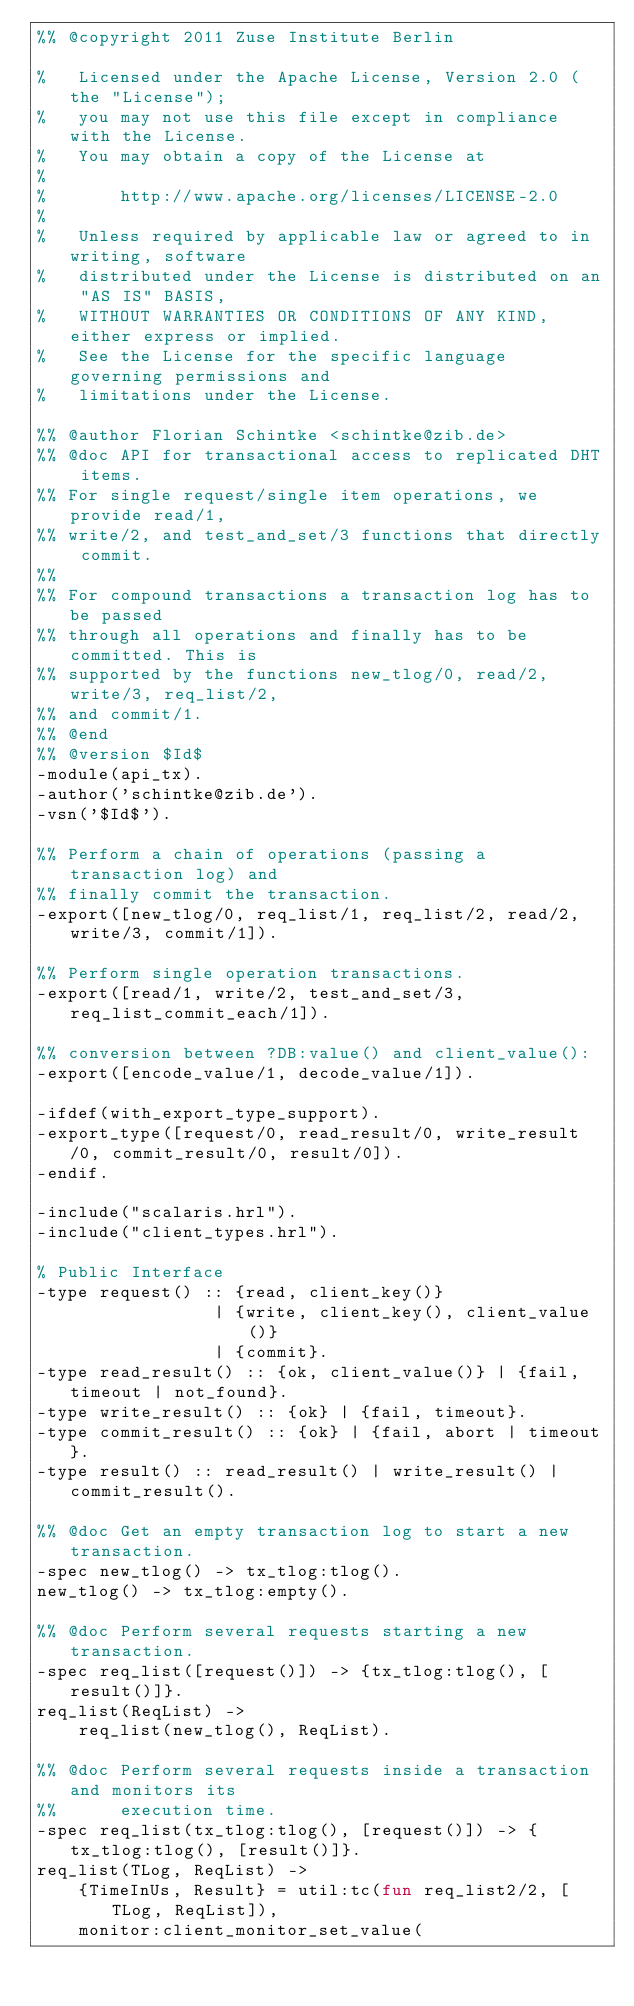<code> <loc_0><loc_0><loc_500><loc_500><_Erlang_>%% @copyright 2011 Zuse Institute Berlin

%   Licensed under the Apache License, Version 2.0 (the "License");
%   you may not use this file except in compliance with the License.
%   You may obtain a copy of the License at
%
%       http://www.apache.org/licenses/LICENSE-2.0
%
%   Unless required by applicable law or agreed to in writing, software
%   distributed under the License is distributed on an "AS IS" BASIS,
%   WITHOUT WARRANTIES OR CONDITIONS OF ANY KIND, either express or implied.
%   See the License for the specific language governing permissions and
%   limitations under the License.

%% @author Florian Schintke <schintke@zib.de>
%% @doc API for transactional access to replicated DHT items.
%% For single request/single item operations, we provide read/1,
%% write/2, and test_and_set/3 functions that directly commit.
%%
%% For compound transactions a transaction log has to be passed
%% through all operations and finally has to be committed. This is
%% supported by the functions new_tlog/0, read/2, write/3, req_list/2,
%% and commit/1.
%% @end
%% @version $Id$
-module(api_tx).
-author('schintke@zib.de').
-vsn('$Id$').

%% Perform a chain of operations (passing a transaction log) and
%% finally commit the transaction.
-export([new_tlog/0, req_list/1, req_list/2, read/2, write/3, commit/1]).

%% Perform single operation transactions.
-export([read/1, write/2, test_and_set/3, req_list_commit_each/1]).

%% conversion between ?DB:value() and client_value():
-export([encode_value/1, decode_value/1]).

-ifdef(with_export_type_support).
-export_type([request/0, read_result/0, write_result/0, commit_result/0, result/0]).
-endif.

-include("scalaris.hrl").
-include("client_types.hrl").

% Public Interface
-type request() :: {read, client_key()}
                 | {write, client_key(), client_value()}
                 | {commit}.
-type read_result() :: {ok, client_value()} | {fail, timeout | not_found}.
-type write_result() :: {ok} | {fail, timeout}.
-type commit_result() :: {ok} | {fail, abort | timeout}.
-type result() :: read_result() | write_result() | commit_result().

%% @doc Get an empty transaction log to start a new transaction.
-spec new_tlog() -> tx_tlog:tlog().
new_tlog() -> tx_tlog:empty().

%% @doc Perform several requests starting a new transaction.
-spec req_list([request()]) -> {tx_tlog:tlog(), [result()]}.
req_list(ReqList) ->
    req_list(new_tlog(), ReqList).

%% @doc Perform several requests inside a transaction and monitors its
%%      execution time.
-spec req_list(tx_tlog:tlog(), [request()]) -> {tx_tlog:tlog(), [result()]}.
req_list(TLog, ReqList) ->
    {TimeInUs, Result} = util:tc(fun req_list2/2, [TLog, ReqList]),
    monitor:client_monitor_set_value(</code> 